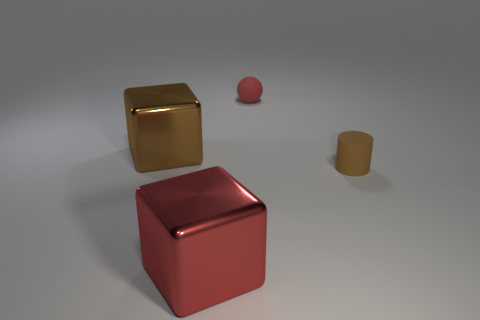There is another large metallic thing that is the same shape as the large red thing; what color is it?
Give a very brief answer. Brown. The brown metallic object has what size?
Make the answer very short. Large. Are there fewer large shiny objects that are right of the tiny red matte ball than tiny green cubes?
Keep it short and to the point. No. Do the big brown object and the tiny thing that is to the left of the tiny brown cylinder have the same material?
Your response must be concise. No. Are there any blocks in front of the large object that is in front of the tiny matte object that is to the right of the small red ball?
Your answer should be very brief. No. Is there anything else that has the same size as the brown matte cylinder?
Ensure brevity in your answer.  Yes. What is the color of the cylinder that is the same material as the red ball?
Give a very brief answer. Brown. There is a thing that is both to the left of the red sphere and behind the big red shiny thing; what is its size?
Your response must be concise. Large. Are there fewer matte cylinders that are to the left of the large brown object than brown blocks that are on the left side of the ball?
Give a very brief answer. Yes. Do the red thing that is in front of the tiny red sphere and the brown thing that is on the right side of the big brown shiny block have the same material?
Give a very brief answer. No. 